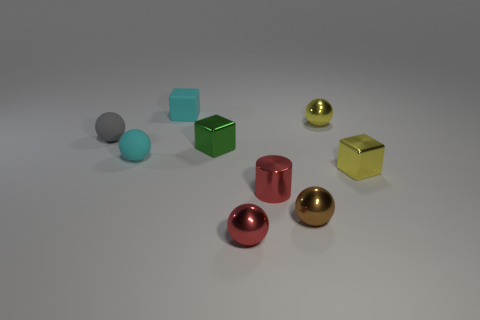Subtract all gray spheres. How many spheres are left? 4 Add 1 small gray objects. How many objects exist? 10 Subtract all cyan cubes. How many brown spheres are left? 1 Subtract all brown spheres. How many spheres are left? 4 Subtract all blocks. How many objects are left? 6 Subtract 2 blocks. How many blocks are left? 1 Subtract all yellow cubes. Subtract all red cylinders. How many cubes are left? 2 Subtract all tiny yellow metallic objects. Subtract all tiny green objects. How many objects are left? 6 Add 8 small gray balls. How many small gray balls are left? 9 Add 4 metal cubes. How many metal cubes exist? 6 